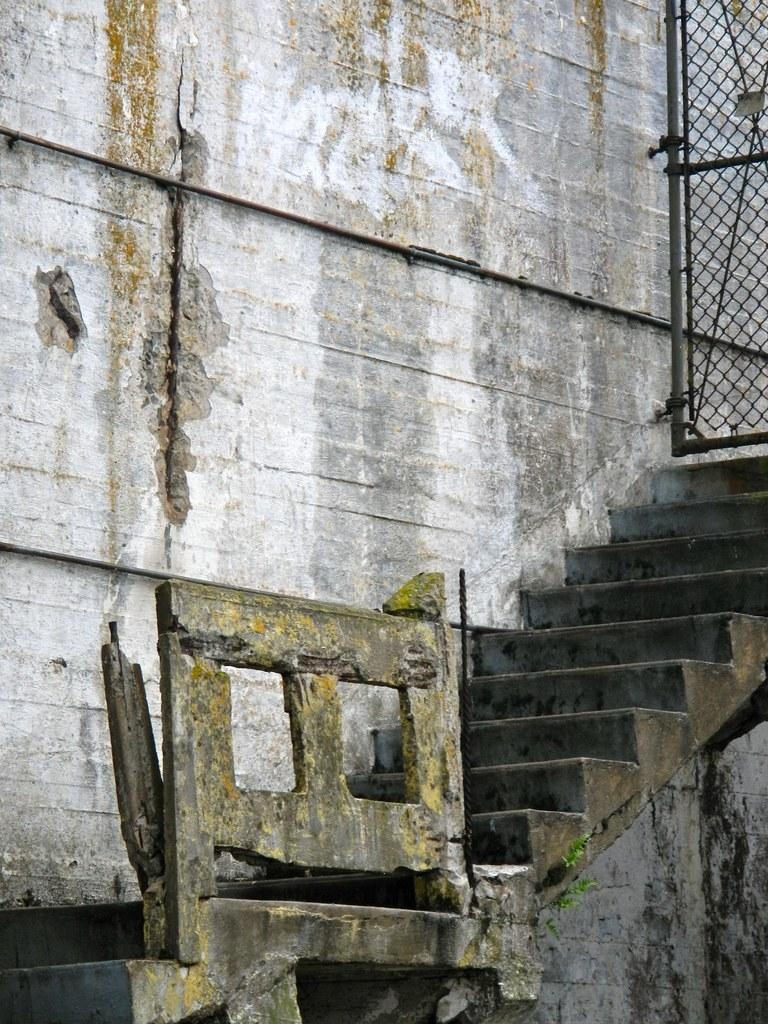What type of architectural feature is present in the image? There are steps in the image. What else can be seen in the image that might be part of a building or structure? There are walls in the image. Is there any material that allows for ventilation or visibility in the image? Yes, there is mesh in the image. Can you describe any unspecified objects in the image? There are some unspecified objects in the image, but their purpose or appearance cannot be determined from the provided facts. How does the bubble affect the sense of smell in the image? There is no bubble present in the image, so it cannot affect the sense of smell. 